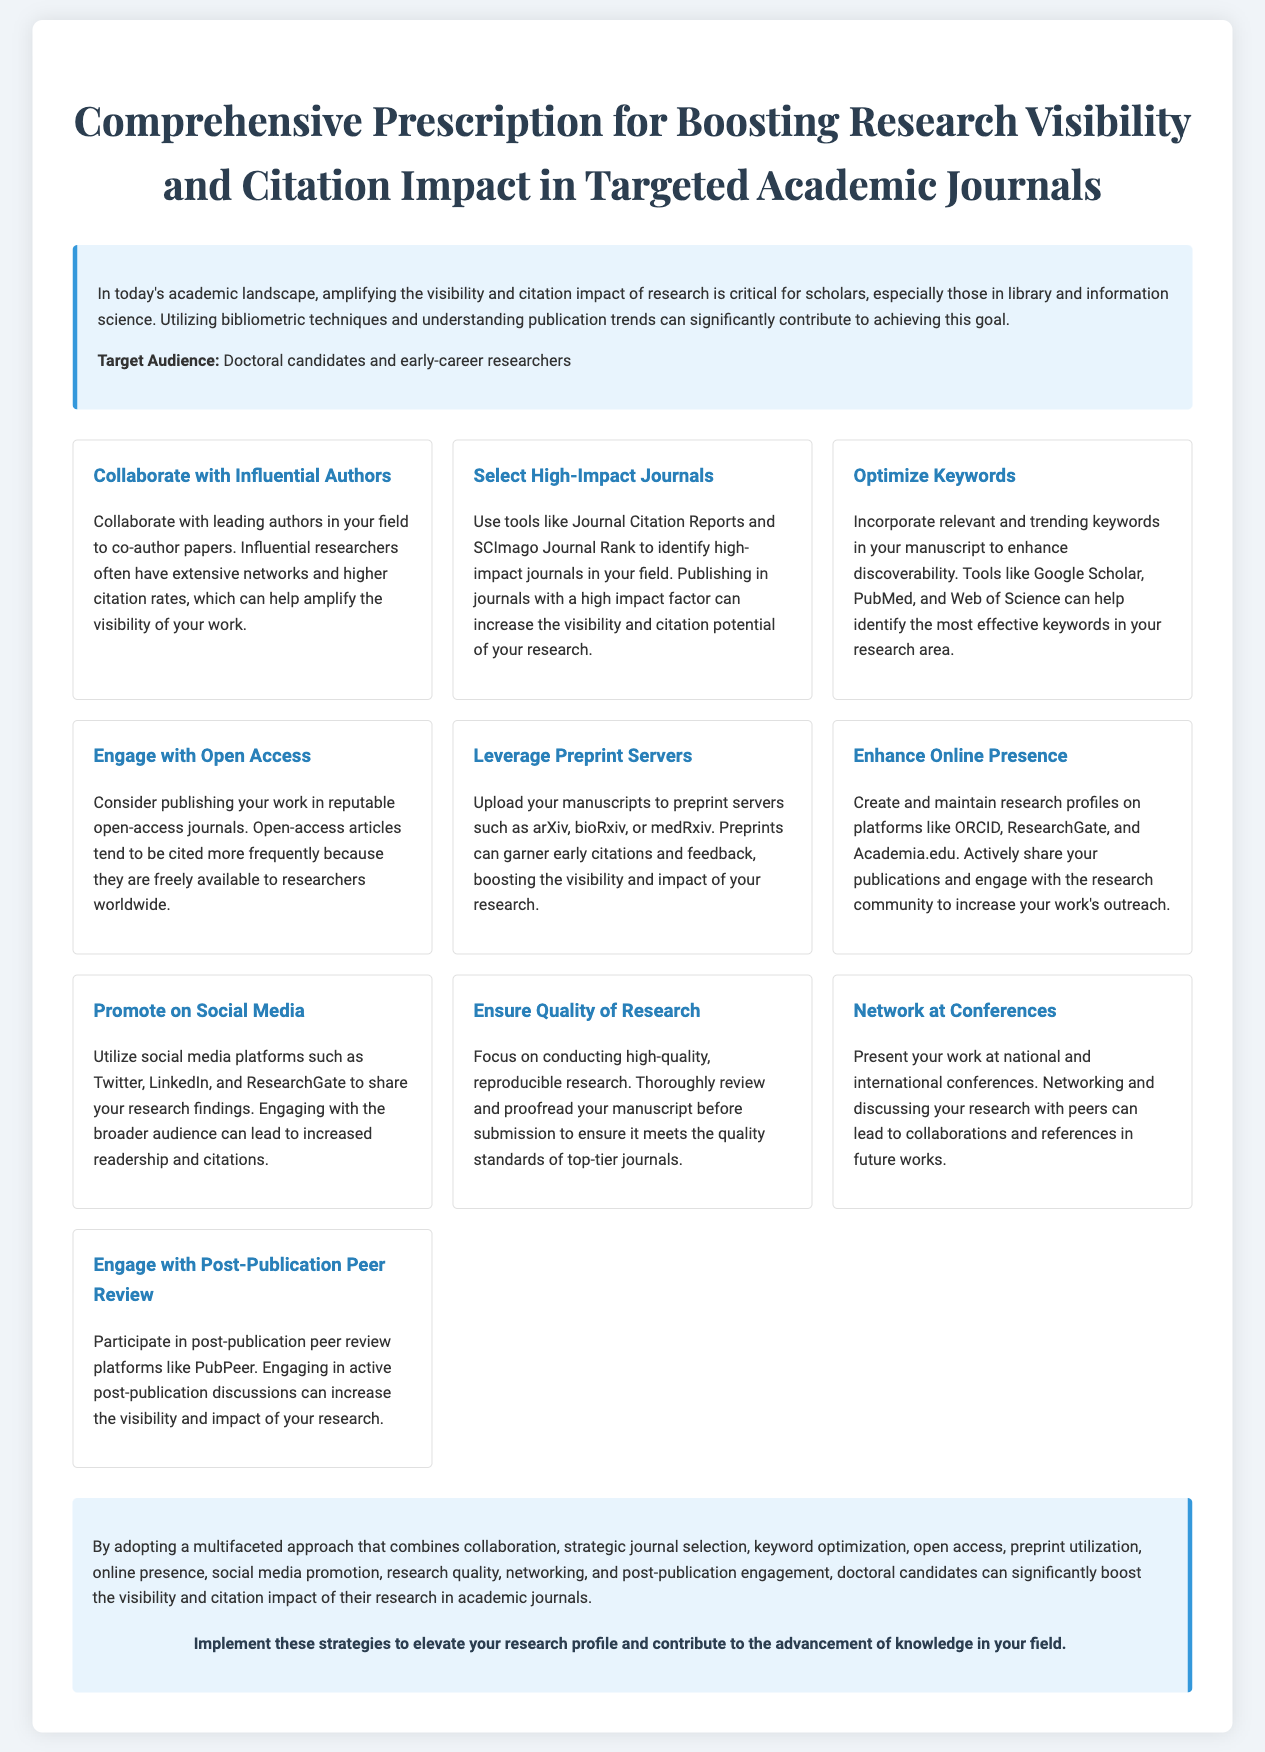What is the title of the document? The title of the document is presented prominently at the top, indicating the main subject.
Answer: Comprehensive Prescription for Boosting Research Visibility and Citation Impact in Targeted Academic Journals Who is the target audience for this document? The document specifies the target audience in the introduction section.
Answer: Doctoral candidates and early-career researchers How many strategies are listed in the document? The number of strategies can be found by counting the individual strategy sections in the document.
Answer: Ten Which platform is suggested for enhancing online presence? The document mentions specific platforms within the strategy for enhancing online presence.
Answer: ORCID, ResearchGate, and Academia.edu What action is recommended to increase research citations? The document provides a clear suggestion as part of its strategies to increase citation impact.
Answer: Publish in reputable open-access journals What is the focus of the strategy related to quality? This question explores the specific advice given about the quality of research in the document.
Answer: Conducting high-quality, reproducible research What is one benefit of collaborating with influential authors? The document explains how collaboration can impact visibility and citation rates.
Answer: Amplify the visibility of your work Which social media platforms are mentioned for promoting research findings? This information can be retrieved by looking at the relevant strategy in the document.
Answer: Twitter, LinkedIn, and ResearchGate What type of engagement is promoted post-publication? The document details post-publication activities that can enhance research visibility.
Answer: Post-publication peer review What visual element distinguishes the introduction section of the document? The introduction section has a unique visual feature as described in the document.
Answer: A border left in blue color 